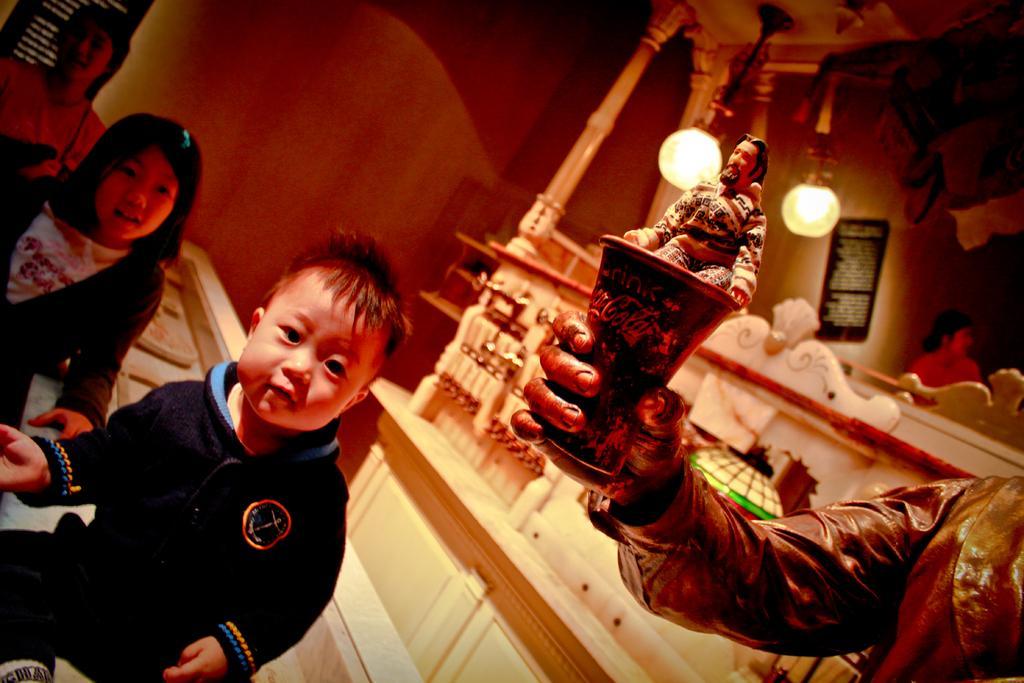Can you describe this image briefly? In this image there is a person and children's are standing and sitting, on the right side of the image there is a depiction of a person holding a glass, on which there is another depiction of a person sitting, behind that there is a wall structure with lamps hanging, beside that there is a woman standing. In the background there are a few boards hanging on the wall. 